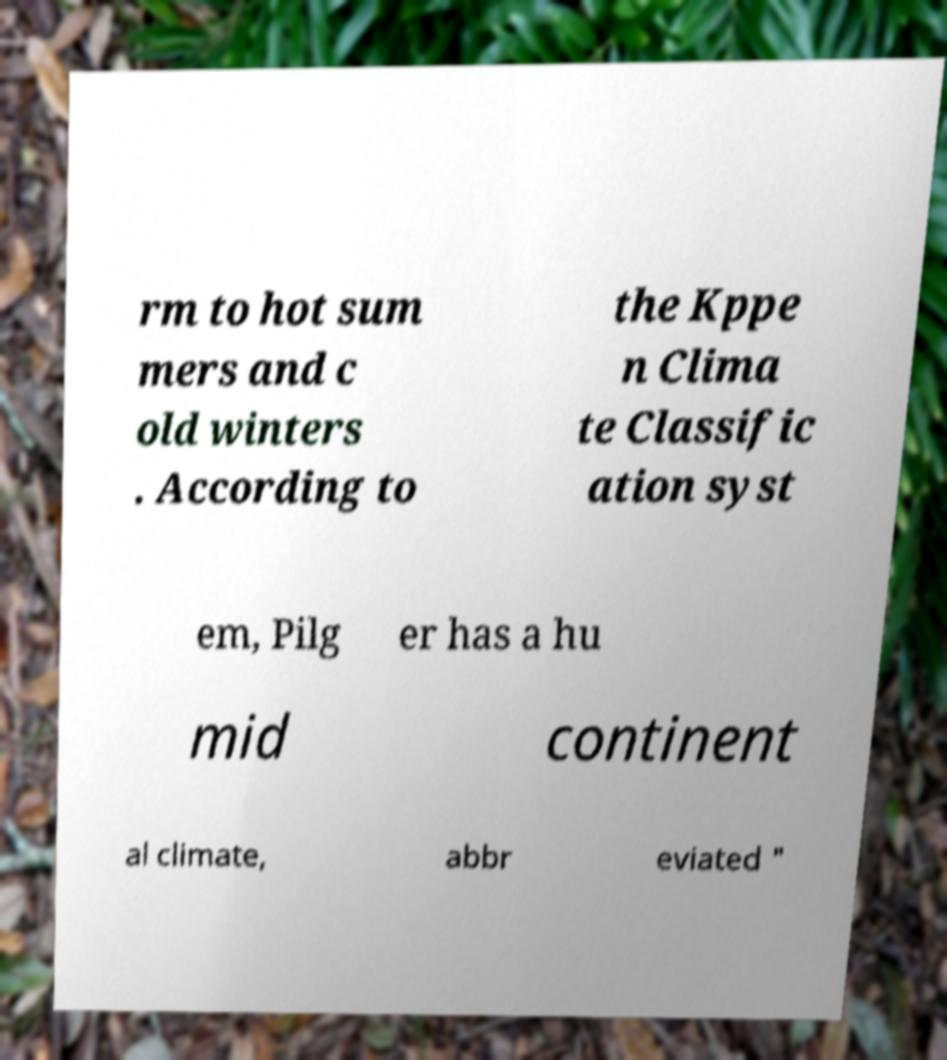Can you read and provide the text displayed in the image?This photo seems to have some interesting text. Can you extract and type it out for me? rm to hot sum mers and c old winters . According to the Kppe n Clima te Classific ation syst em, Pilg er has a hu mid continent al climate, abbr eviated " 